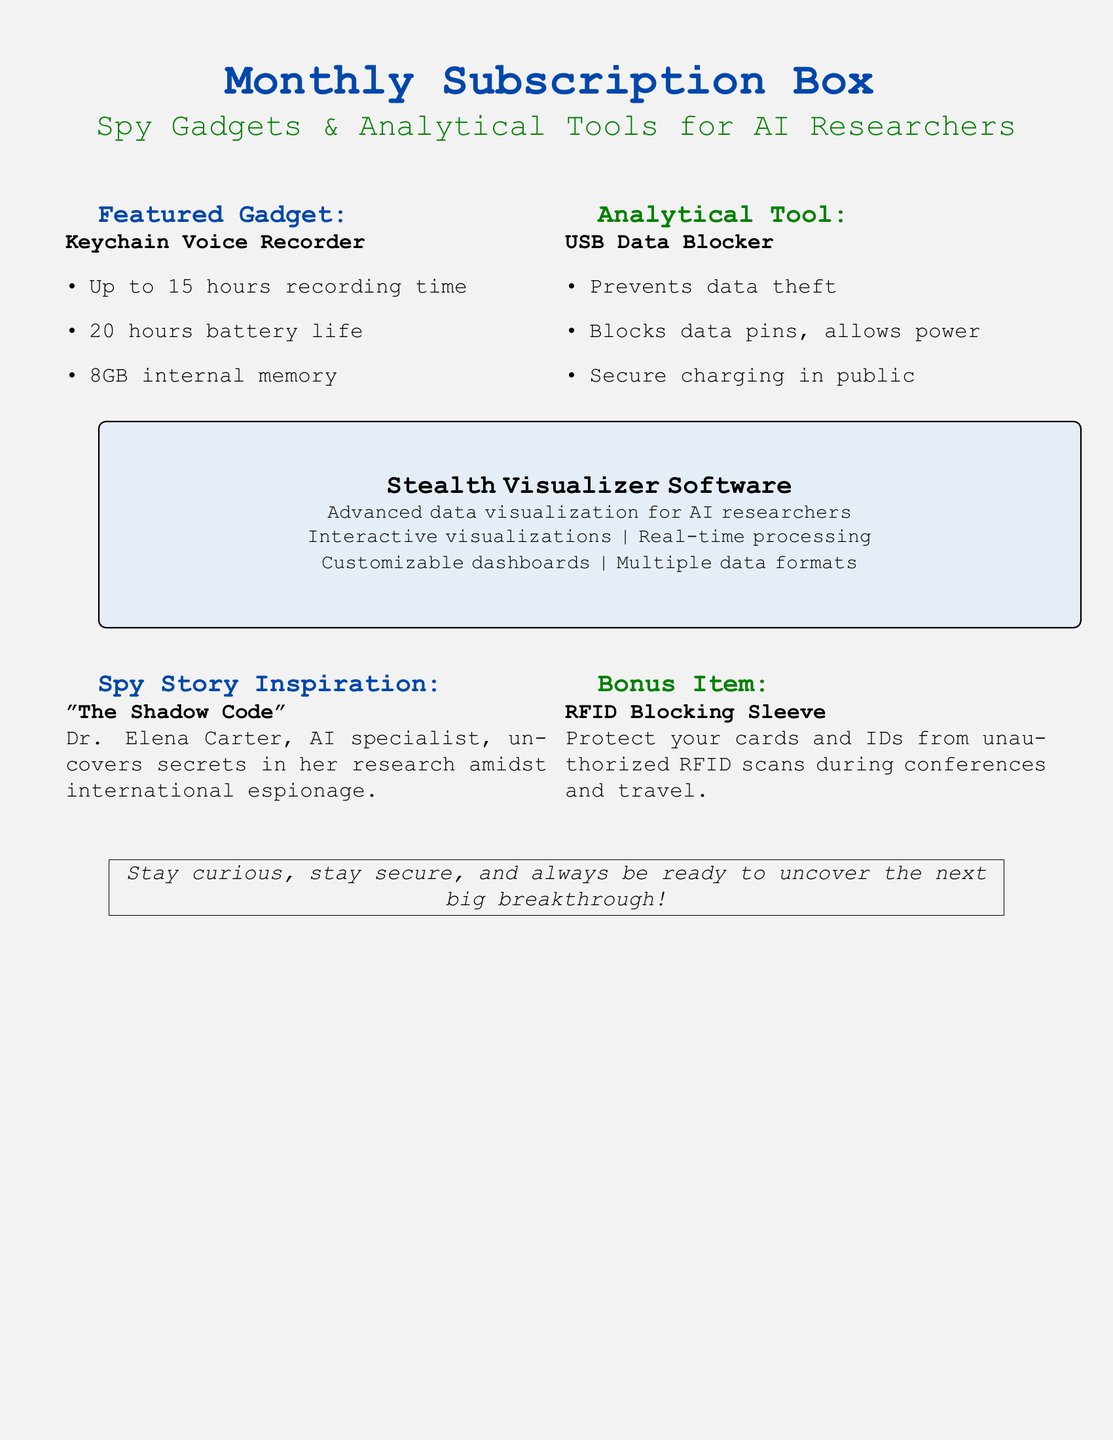what is the featured gadget? The featured gadget is explicitly named in the document.
Answer: Keychain Voice Recorder how many hours of recording time does the Keychain Voice Recorder provide? The document lists the recording time for the Keychain Voice Recorder.
Answer: 15 hours what is the analytical tool included in the subscription box? The document specifies the analytical tool included.
Answer: USB Data Blocker what is the primary purpose of the RFID Blocking Sleeve? The document explains the function of the bonus item.
Answer: Protect your cards and IDs from unauthorized RFID scans what is the title of the spy story featured in the document? The title of the spy story is highlighted in the section of the document.
Answer: The Shadow Code what main feature does the Stealth Visualizer Software provide? The document details the primary function of the software.
Answer: Advanced data visualization how many hours of battery life does the Keychain Voice Recorder have? The battery life of the Keychain Voice Recorder is mentioned in the document.
Answer: 20 hours what type of security does the USB Data Blocker offer? The document specifies the security feature provided by the USB Data Blocker.
Answer: Prevents data theft what is the color scheme used for the Monthly Subscription Box heading? The document describes the colors used for the headings.
Answer: Spy blue and AI green 